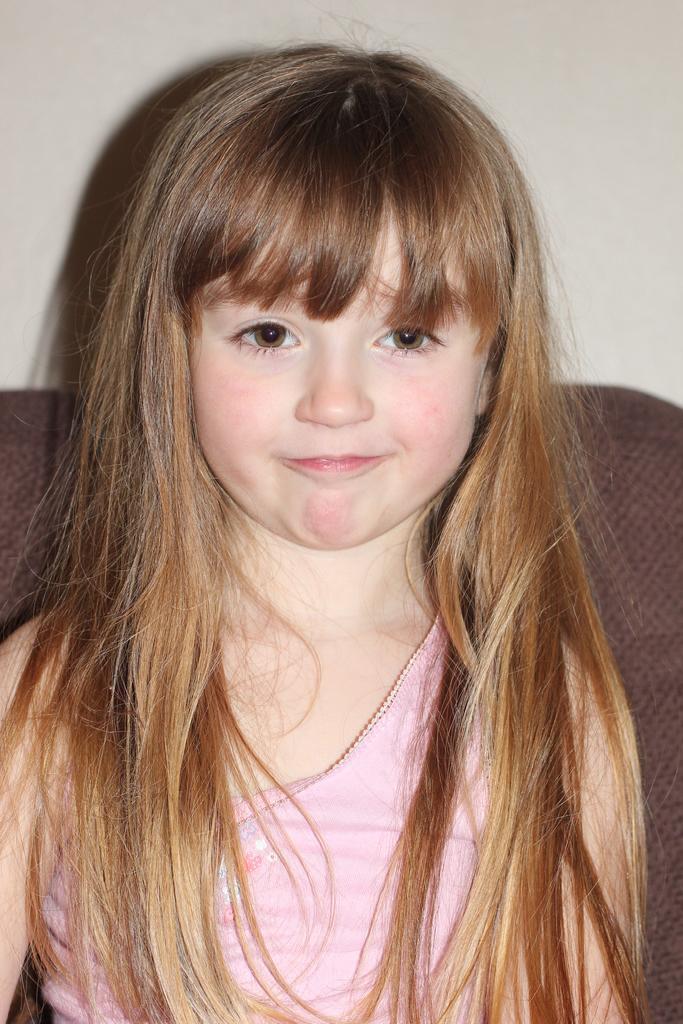Describe this image in one or two sentences. This is the picture of a girl in pink dress who is sitting on the sofa. 